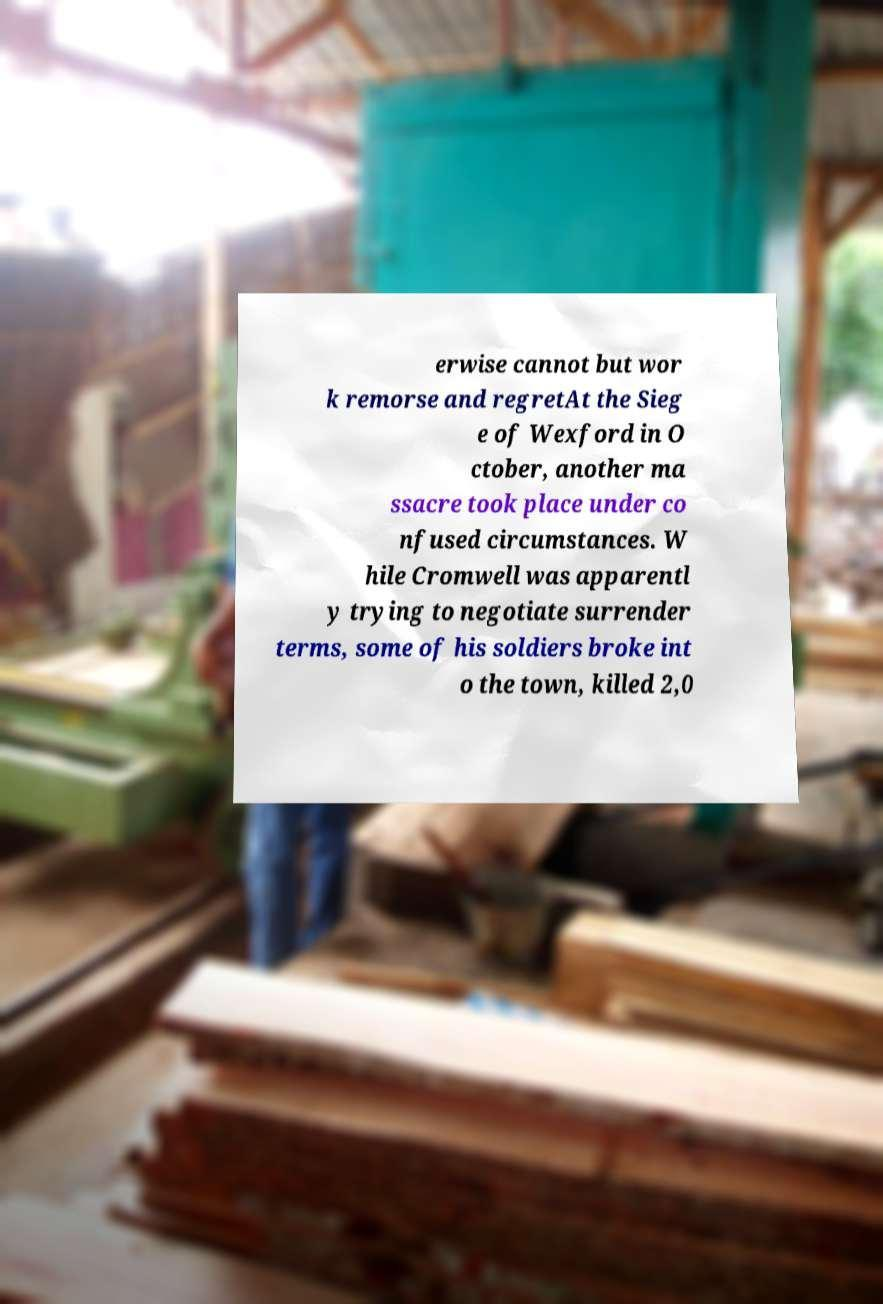Can you read and provide the text displayed in the image?This photo seems to have some interesting text. Can you extract and type it out for me? erwise cannot but wor k remorse and regretAt the Sieg e of Wexford in O ctober, another ma ssacre took place under co nfused circumstances. W hile Cromwell was apparentl y trying to negotiate surrender terms, some of his soldiers broke int o the town, killed 2,0 